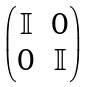<formula> <loc_0><loc_0><loc_500><loc_500>\begin{pmatrix} \mathbb { I } & 0 \\ 0 & \mathbb { I } \end{pmatrix}</formula> 